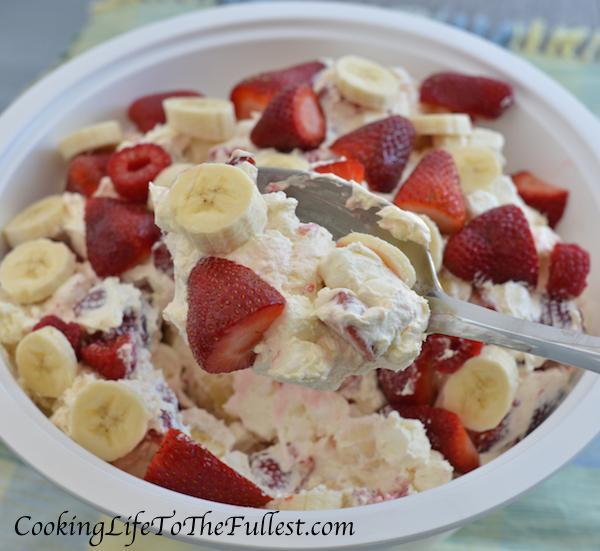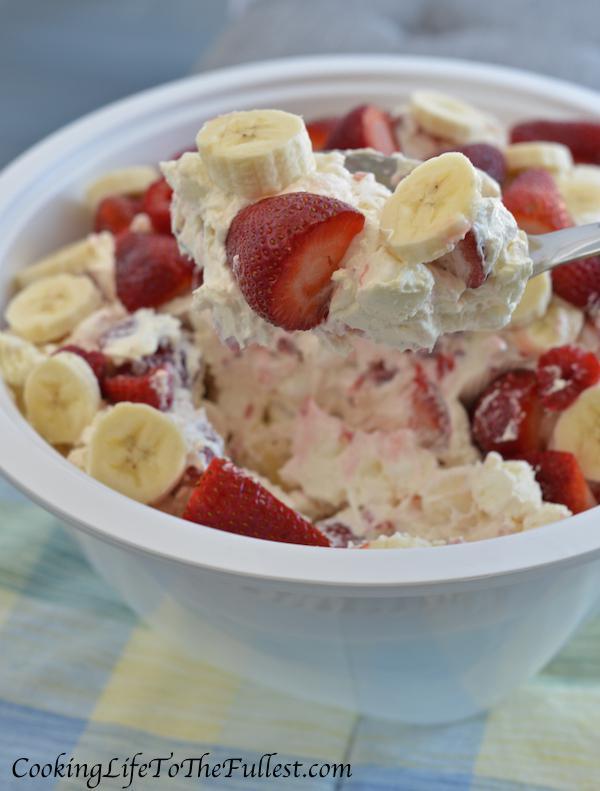The first image is the image on the left, the second image is the image on the right. Evaluate the accuracy of this statement regarding the images: "An image shows a round bowl of fruit dessert sitting on a wood-grain board, with a piece of silverware laying flat on the right side of the bowl.". Is it true? Answer yes or no. No. The first image is the image on the left, the second image is the image on the right. Assess this claim about the two images: "There is cutlery outside of the bowl.". Correct or not? Answer yes or no. No. 